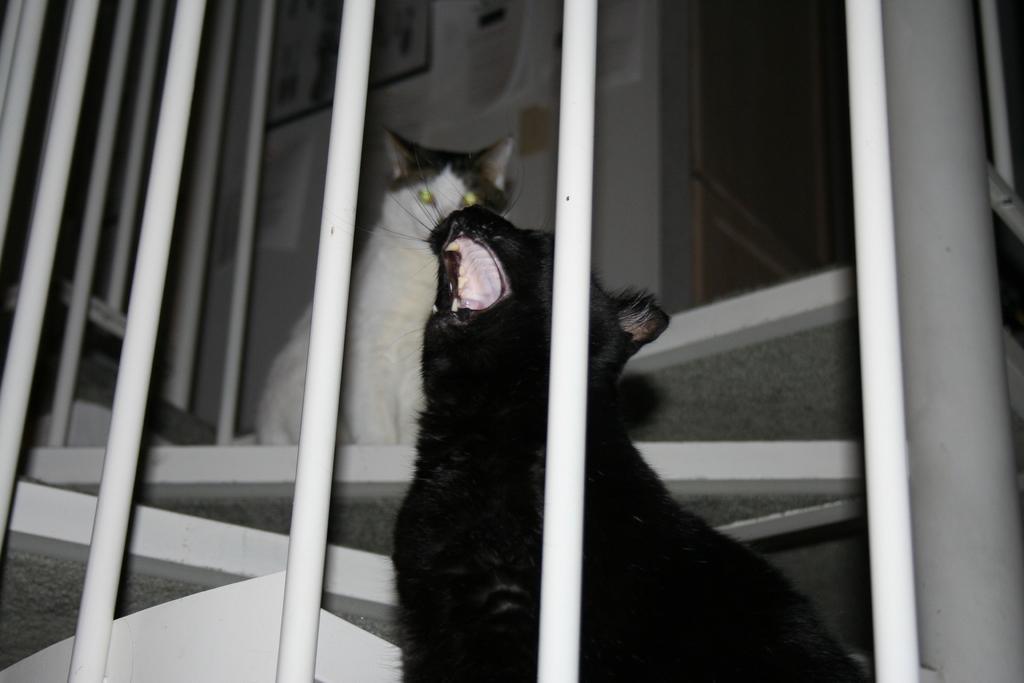Could you give a brief overview of what you see in this image? In this image, we can see some animals, stairs. We can see the railing and the wall with some objects. 